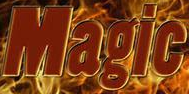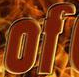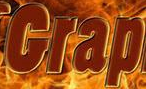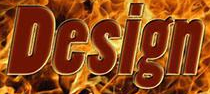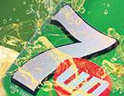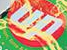What words are shown in these images in order, separated by a semicolon? Magic; of; Grap; Design; 7; up 